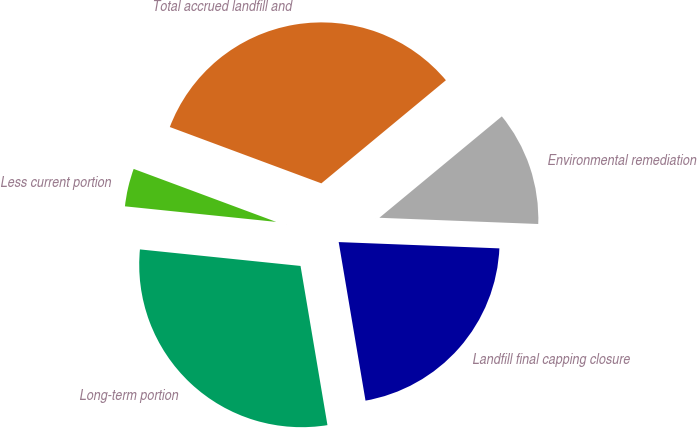Convert chart to OTSL. <chart><loc_0><loc_0><loc_500><loc_500><pie_chart><fcel>Landfill final capping closure<fcel>Environmental remediation<fcel>Total accrued landfill and<fcel>Less current portion<fcel>Long-term portion<nl><fcel>21.71%<fcel>11.63%<fcel>33.33%<fcel>4.03%<fcel>29.3%<nl></chart> 